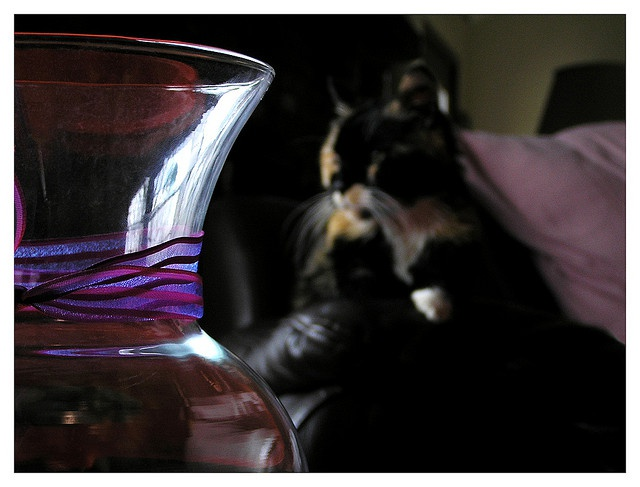Describe the objects in this image and their specific colors. I can see vase in white, black, maroon, and gray tones and cat in white, black, and gray tones in this image. 